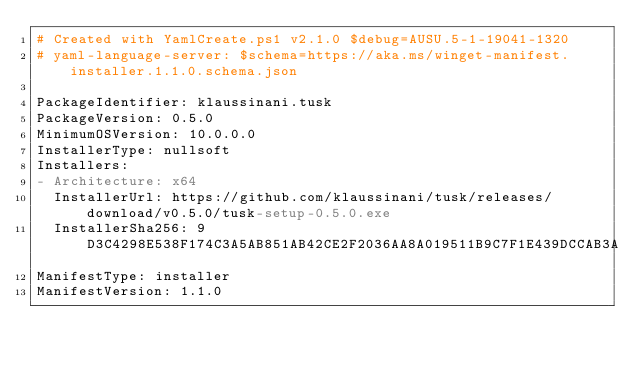<code> <loc_0><loc_0><loc_500><loc_500><_YAML_># Created with YamlCreate.ps1 v2.1.0 $debug=AUSU.5-1-19041-1320
# yaml-language-server: $schema=https://aka.ms/winget-manifest.installer.1.1.0.schema.json

PackageIdentifier: klaussinani.tusk
PackageVersion: 0.5.0
MinimumOSVersion: 10.0.0.0
InstallerType: nullsoft
Installers:
- Architecture: x64
  InstallerUrl: https://github.com/klaussinani/tusk/releases/download/v0.5.0/tusk-setup-0.5.0.exe
  InstallerSha256: 9D3C4298E538F174C3A5AB851AB42CE2F2036AA8A019511B9C7F1E439DCCAB3A
ManifestType: installer
ManifestVersion: 1.1.0
</code> 